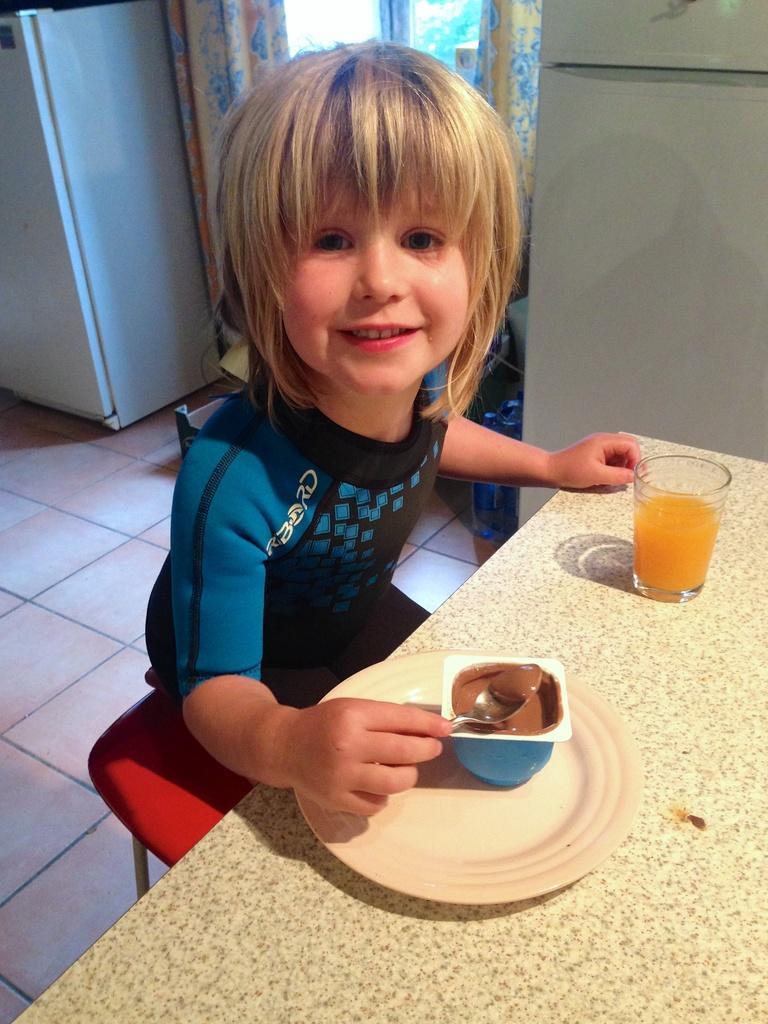How would you summarize this image in a sentence or two? In this image I can see the child sitting and I can also see the food in the plate and the glass is on the cream color surface. In the background I can see the refrigerator, few windows and curtains. 